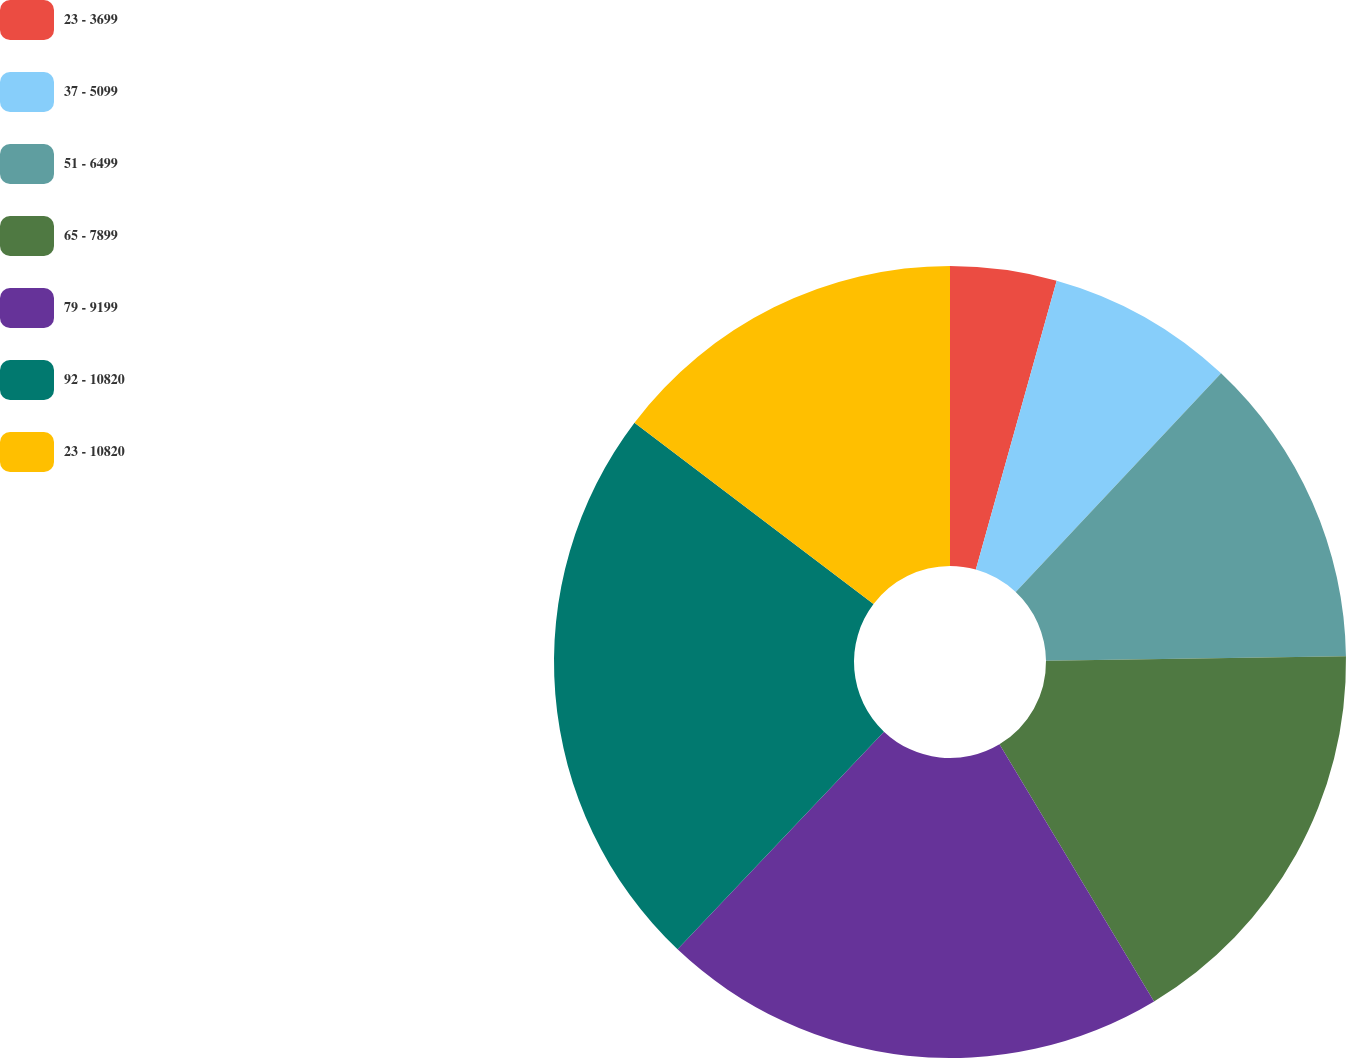Convert chart. <chart><loc_0><loc_0><loc_500><loc_500><pie_chart><fcel>23 - 3699<fcel>37 - 5099<fcel>51 - 6499<fcel>65 - 7899<fcel>79 - 9199<fcel>92 - 10820<fcel>23 - 10820<nl><fcel>4.34%<fcel>7.66%<fcel>12.77%<fcel>16.61%<fcel>20.69%<fcel>23.25%<fcel>14.67%<nl></chart> 